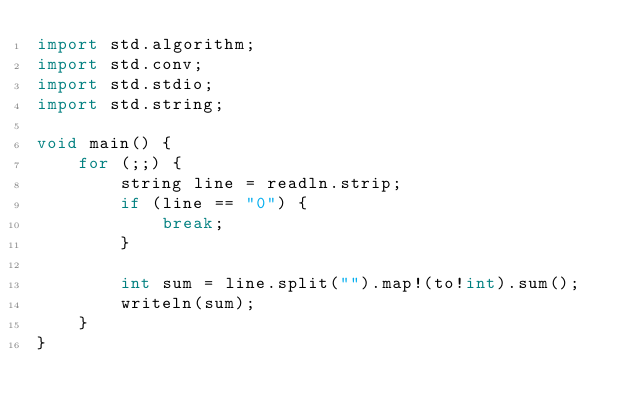Convert code to text. <code><loc_0><loc_0><loc_500><loc_500><_D_>import std.algorithm;
import std.conv;
import std.stdio;
import std.string;

void main() {
	for (;;) {
		string line = readln.strip;
		if (line == "0") {
			break;
		}

		int sum = line.split("").map!(to!int).sum();
		writeln(sum);
	}
}</code> 